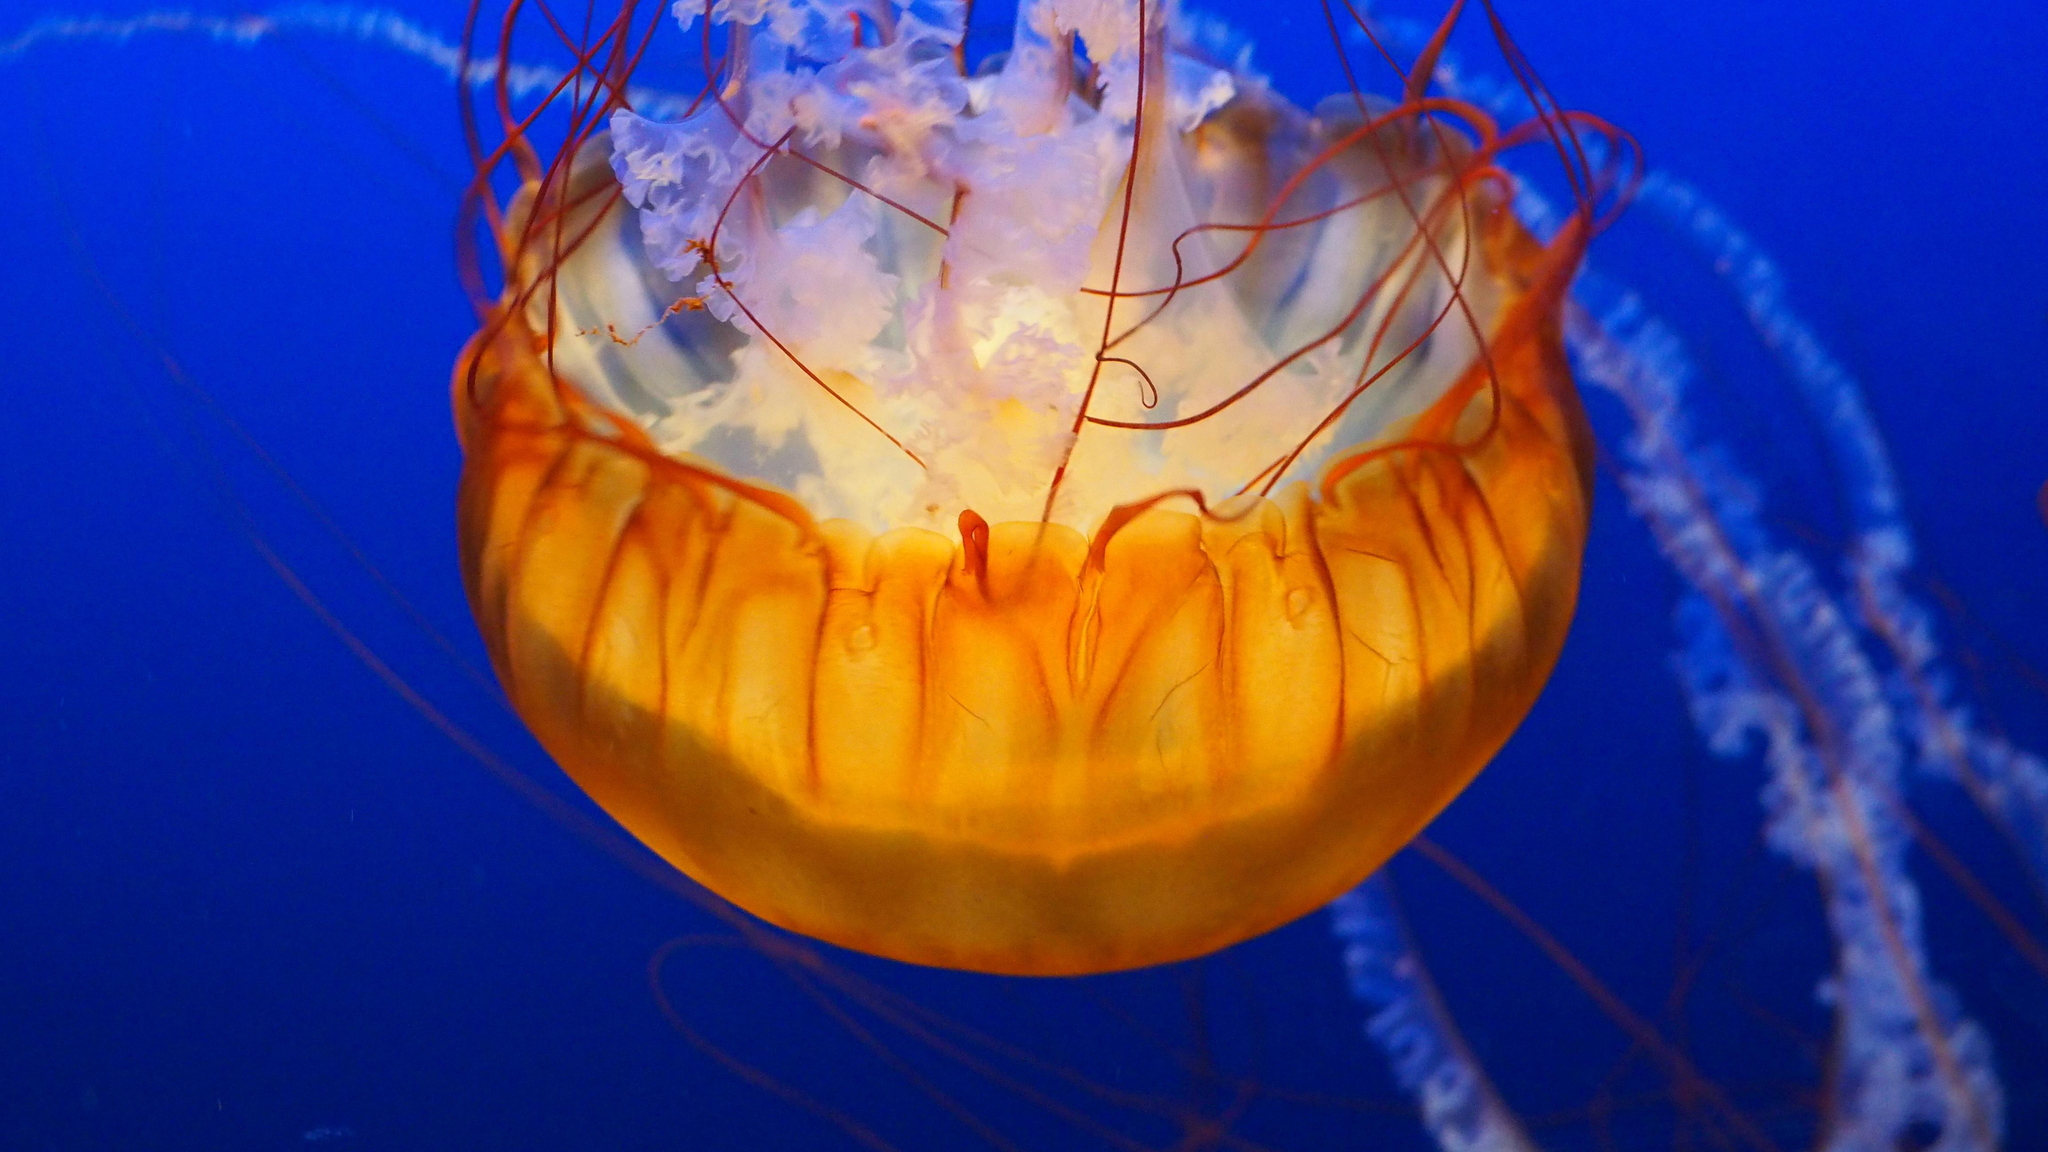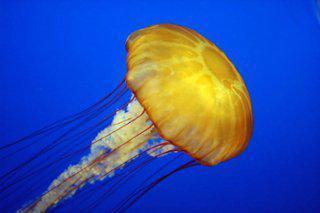The first image is the image on the left, the second image is the image on the right. For the images displayed, is the sentence "There are a total of three jellyfish." factually correct? Answer yes or no. No. 